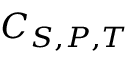<formula> <loc_0><loc_0><loc_500><loc_500>C _ { S , P , T }</formula> 